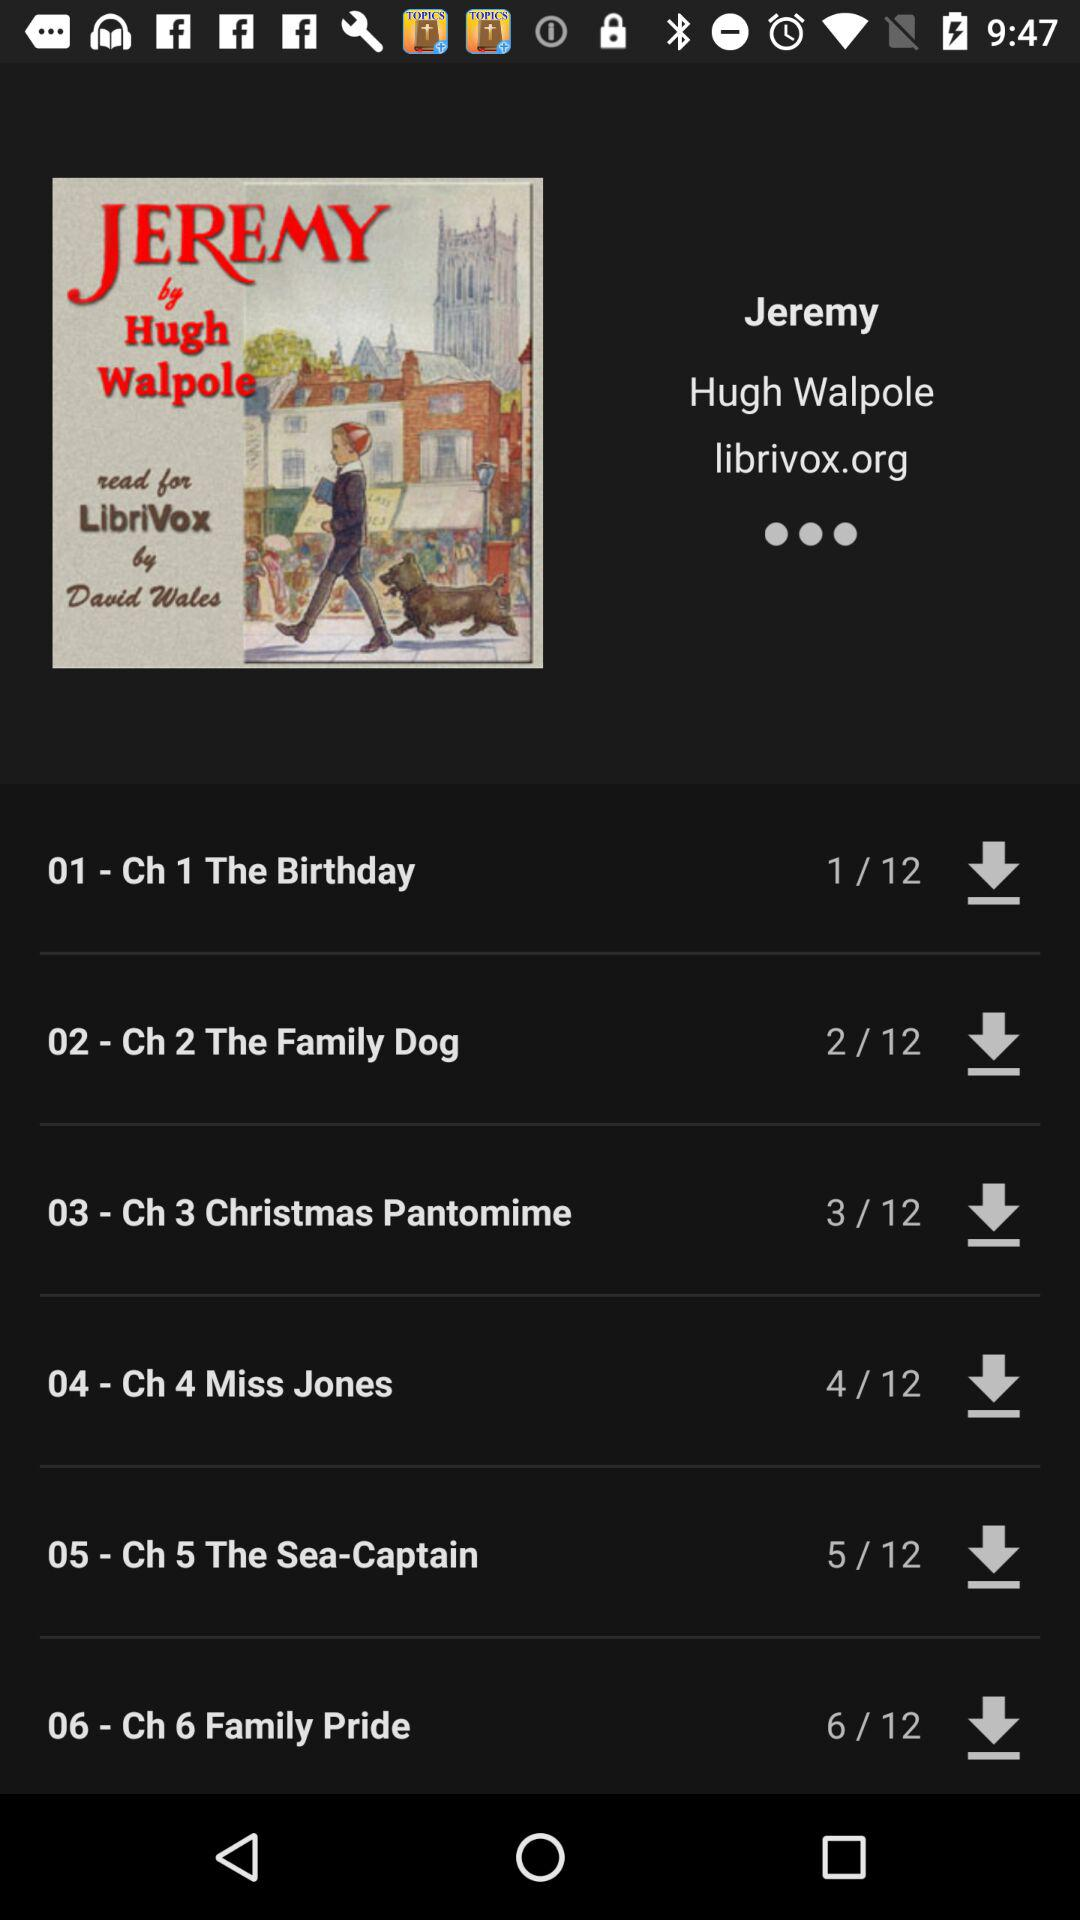Who is the author of Jeremy? The author is "Hugh Walpole". 